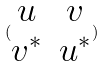Convert formula to latex. <formula><loc_0><loc_0><loc_500><loc_500>( \begin{matrix} u & v \\ v ^ { * } & u ^ { * } \end{matrix} )</formula> 